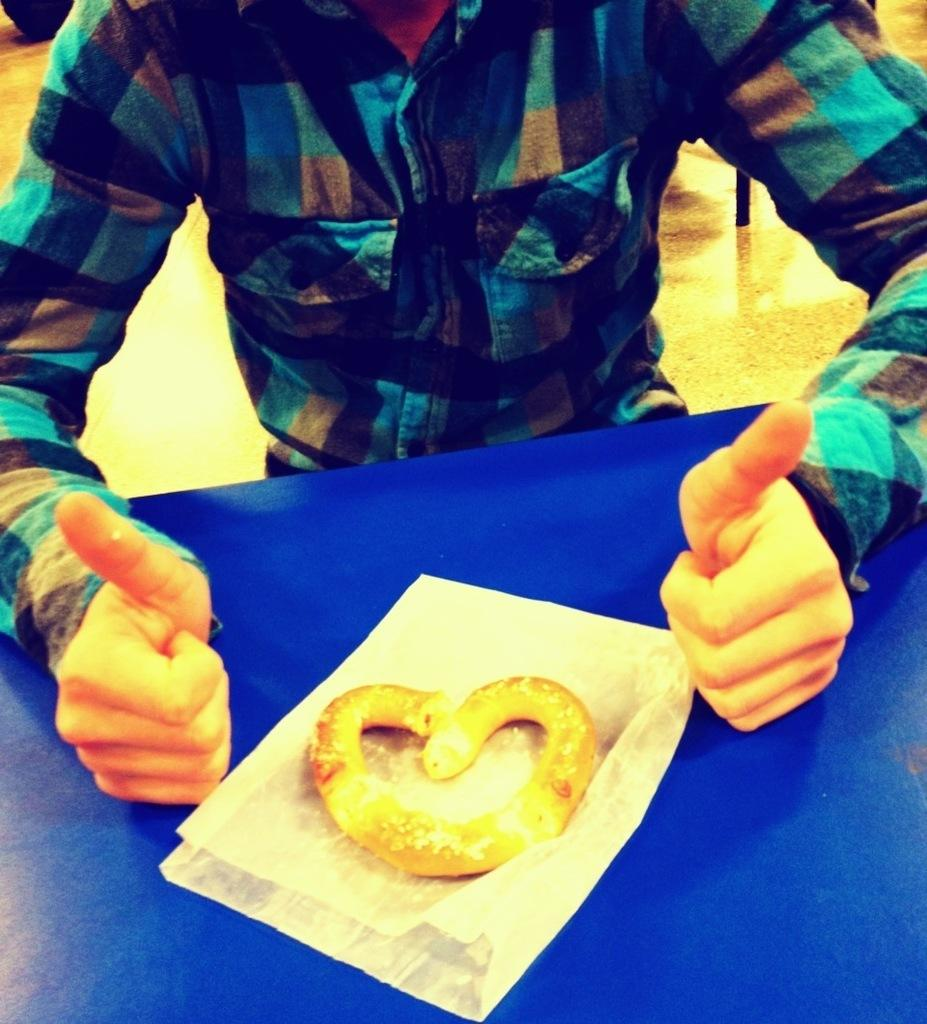What is the main object in the center of the image? There is a table in the center of the image. What can be found on the table? There are food items and a paper on the table. What is visible at the bottom of the image? The top of the image shows a floor. Can you describe the person in the image? A person is visible in the image. What type of vest can be seen on the person in the image? There is no vest visible on the person in the image. Is there a river flowing through the room in the image? There is no river present in the image; it features a table, food items, a paper, a floor, and a person. 